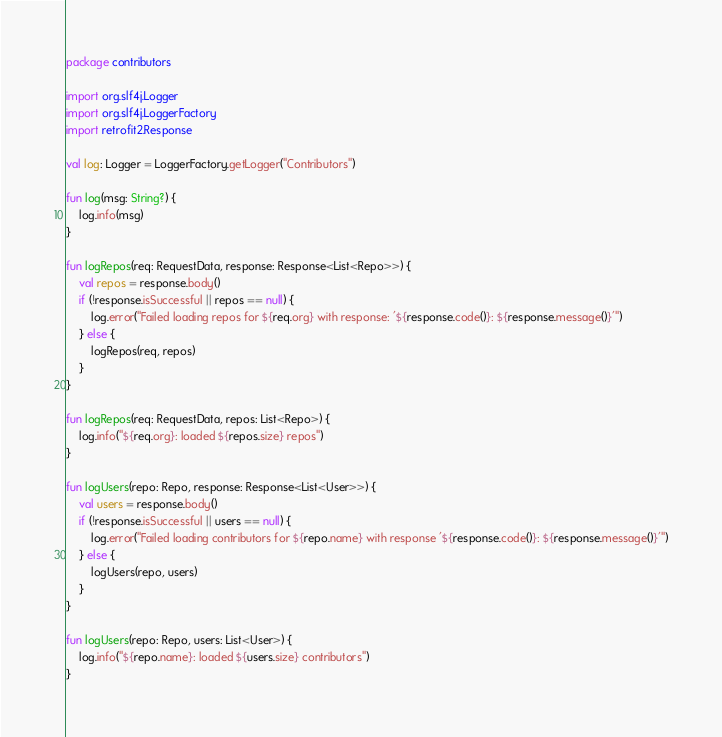<code> <loc_0><loc_0><loc_500><loc_500><_Kotlin_>package contributors

import org.slf4j.Logger
import org.slf4j.LoggerFactory
import retrofit2.Response

val log: Logger = LoggerFactory.getLogger("Contributors")

fun log(msg: String?) {
    log.info(msg)
}

fun logRepos(req: RequestData, response: Response<List<Repo>>) {
    val repos = response.body()
    if (!response.isSuccessful || repos == null) {
        log.error("Failed loading repos for ${req.org} with response: '${response.code()}: ${response.message()}'")
    } else {
        logRepos(req, repos)
    }
}

fun logRepos(req: RequestData, repos: List<Repo>) {
    log.info("${req.org}: loaded ${repos.size} repos")
}

fun logUsers(repo: Repo, response: Response<List<User>>) {
    val users = response.body()
    if (!response.isSuccessful || users == null) {
        log.error("Failed loading contributors for ${repo.name} with response '${response.code()}: ${response.message()}'")
    } else {
        logUsers(repo, users)
    }
}

fun logUsers(repo: Repo, users: List<User>) {
    log.info("${repo.name}: loaded ${users.size} contributors")
}</code> 